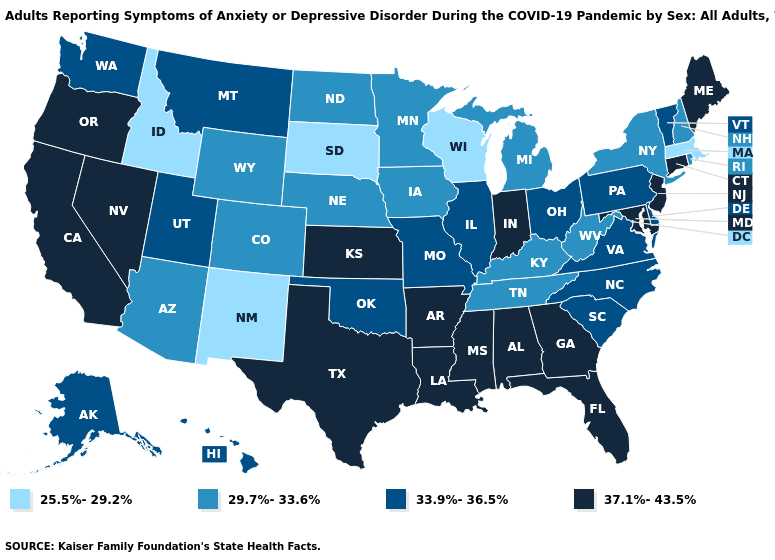Among the states that border New Jersey , which have the highest value?
Keep it brief. Delaware, Pennsylvania. Does California have the highest value in the West?
Write a very short answer. Yes. What is the lowest value in the USA?
Short answer required. 25.5%-29.2%. Does the map have missing data?
Keep it brief. No. Does Texas have the highest value in the South?
Answer briefly. Yes. Among the states that border Ohio , does Indiana have the highest value?
Concise answer only. Yes. What is the value of Arizona?
Quick response, please. 29.7%-33.6%. What is the value of Maine?
Short answer required. 37.1%-43.5%. Name the states that have a value in the range 33.9%-36.5%?
Concise answer only. Alaska, Delaware, Hawaii, Illinois, Missouri, Montana, North Carolina, Ohio, Oklahoma, Pennsylvania, South Carolina, Utah, Vermont, Virginia, Washington. Does New Jersey have a higher value than North Dakota?
Give a very brief answer. Yes. What is the value of Pennsylvania?
Quick response, please. 33.9%-36.5%. What is the value of Maryland?
Concise answer only. 37.1%-43.5%. What is the value of California?
Keep it brief. 37.1%-43.5%. Name the states that have a value in the range 25.5%-29.2%?
Give a very brief answer. Idaho, Massachusetts, New Mexico, South Dakota, Wisconsin. Among the states that border Montana , does North Dakota have the highest value?
Keep it brief. Yes. 